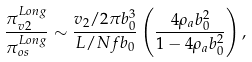<formula> <loc_0><loc_0><loc_500><loc_500>\frac { \pi ^ { L o n g } _ { v 2 } } { \pi ^ { L o n g } _ { o s } } \sim \frac { v _ { 2 } / 2 \pi b _ { 0 } ^ { 3 } } { L / N f b _ { 0 } } \left ( \frac { 4 \rho _ { a } b _ { 0 } ^ { 2 } } { 1 - 4 \rho _ { a } b _ { 0 } ^ { 2 } } \right ) ,</formula> 